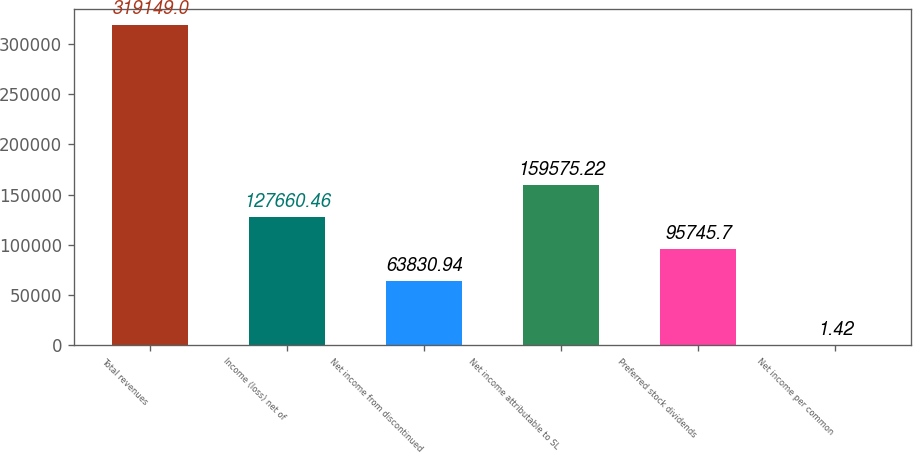Convert chart to OTSL. <chart><loc_0><loc_0><loc_500><loc_500><bar_chart><fcel>Total revenues<fcel>Income (loss) net of<fcel>Net income from discontinued<fcel>Net income attributable to SL<fcel>Preferred stock dividends<fcel>Net income per common<nl><fcel>319149<fcel>127660<fcel>63830.9<fcel>159575<fcel>95745.7<fcel>1.42<nl></chart> 